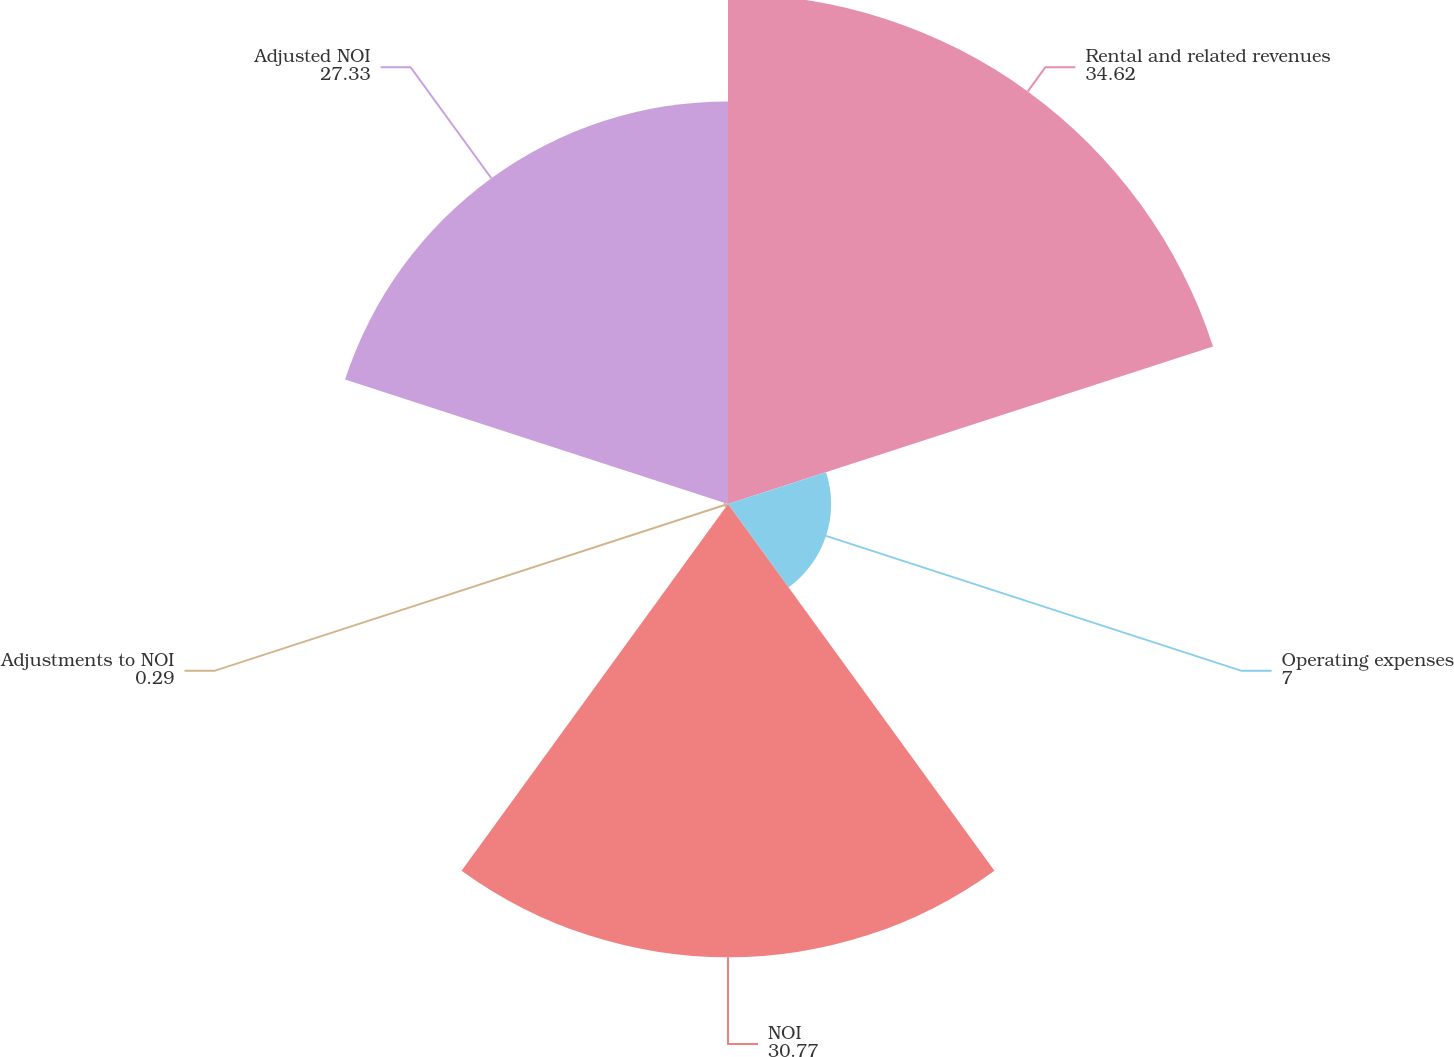Convert chart. <chart><loc_0><loc_0><loc_500><loc_500><pie_chart><fcel>Rental and related revenues<fcel>Operating expenses<fcel>NOI<fcel>Adjustments to NOI<fcel>Adjusted NOI<nl><fcel>34.62%<fcel>7.0%<fcel>30.77%<fcel>0.29%<fcel>27.33%<nl></chart> 